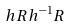Convert formula to latex. <formula><loc_0><loc_0><loc_500><loc_500>h R h ^ { - 1 } R</formula> 